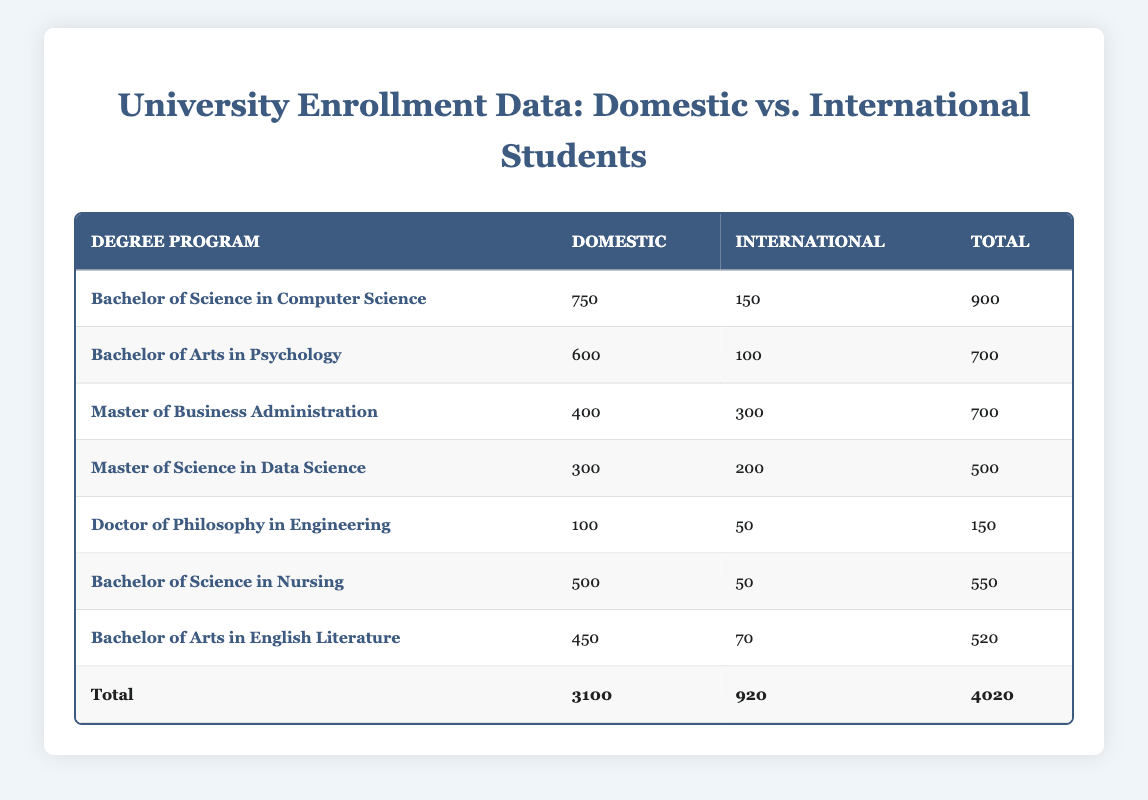What is the total enrollment for the Bachelor of Science in Computer Science program? From the table, I can find the row for the Bachelor of Science in Computer Science, which shows Domestic enrollment as 750 and International enrollment as 150. Adding these figures gives 750 + 150 = 900.
Answer: 900 How many more domestic students are enrolled in the Bachelor of Arts in Psychology compared to the Doctor of Philosophy in Engineering? The table shows 600 domestic students in Psychology and 100 domestic students in Engineering. To find the difference, I subtract 100 from 600, which results in 600 - 100 = 500.
Answer: 500 What is the average number of international students across all degree programs? To find the average, I sum the international enrollments: 150 + 100 + 300 + 200 + 50 + 50 + 70 = 1020. There are 7 program entries, so I calculate the average by dividing the total by 7. Therefore, 1020 / 7 = 145.71, rounded to 146 if needed.
Answer: 146 Is the total enrollment for the Master of Science in Data Science less than the Bachelor of Arts in English Literature? The Master of Science in Data Science has a total enrollment of 500, while the Bachelor of Arts in English Literature has a total enrollment of 520. Since 500 is less than 520, the statement is true.
Answer: Yes What is the total number of domestic students across all programs? I calculate the total by adding domestic enrollments from each program: 750 + 600 + 400 + 300 + 100 + 500 + 450 = 3100.
Answer: 3100 Which degree program has the highest enrollment, and what is that total? Looking through the total enrollments for each program, I see that the Bachelor of Science in Computer Science has the highest total at 900 students.
Answer: Bachelor of Science in Computer Science, 900 How many international students are enrolled in the Master of Business Administration and Master of Science in Data Science combined? The Master of Business Administration has 300 international students and the Master of Science in Data Science has 200. Adding these gives 300 + 200 = 500.
Answer: 500 Is it true that more than 50% of the Bachelor of Science in Nursing students are international? The Bachelor of Science in Nursing has 500 domestic and 50 international students. To find the percentage of international students, I calculate (50 / (500 + 50)) * 100 = (50 / 550) * 100 ≈ 9.09%. Since 9.09% is not more than 50, the statement is false.
Answer: No 